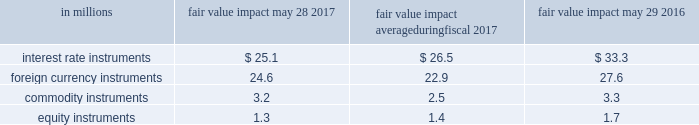We are exposed to market risk stemming from changes in interest and foreign exchange rates and commod- ity and equity prices .
Changes in these factors could cause fl uctuations in our earnings and cash fl ows .
In the normal course of business , we actively manage our exposure to these market risks by entering into vari- ous hedging transactions , authorized under established policies that place clear controls on these activities .
Th e counterparties in these transactions are generally highly rated institutions .
We establish credit limits for each counterparty .
Our hedging transactions include but are not limited to a variety of derivative fi nancial instruments .
For information on interest rate , foreign exchange , commodity price , and equity instrument risk , please see note 7 to the consolidated financial statements on page 61 of this report .
Value at risk th e estimates in the table below are intended to mea- sure the maximum potential fair value we could lose in one day from adverse changes in market interest rates , foreign exchange rates , commodity prices , and equity prices under normal market conditions .
A monte carlo value-at-risk ( var ) methodology was used to quantify the market risk for our exposures .
Th e models assumed normal market conditions and used a 95 percent confi - dence level .
Th e var calculation used historical interest and for- eign exchange rates , and commodity and equity prices from the past year to estimate the potential volatility and correlation of these rates in the future .
Th e market data were drawn from the riskmetrics 2122 data set .
Th e calculations are not intended to represent actual losses in fair value that we expect to incur .
Further , since the hedging instrument ( the derivative ) inversely cor- relates with the underlying exposure , we would expect that any loss or gain in the fair value of our derivatives would be generally off set by an increase or decrease in the fair value of the underlying exposure .
Th e positions included in the calculations were : debt ; investments ; interest rate swaps ; foreign exchange forwards ; com- modity swaps , futures and options ; and equity instru- ments .
Th e calculations do not include the underlying foreign exchange and commodities or equity-related positions that are off set by these market-risk-sensitive instruments .
Th e table below presents the estimated maximum potential var arising from a one-day loss in fair value for our interest rate , foreign currency , commodity , and equity market-risk-sensitive instruments outstanding as of may 28 , 2017 , and may 29 , 2016 , and the average fair value impact during the year ended may 28 , 2017. .
Quantitative and qualitative disclosures about market risk 44 general mills .
What is the total average fair value impact of all the instruments? 
Computations: (((26.5 + 22.9) + 2.5) + 1.4)
Answer: 53.3. 